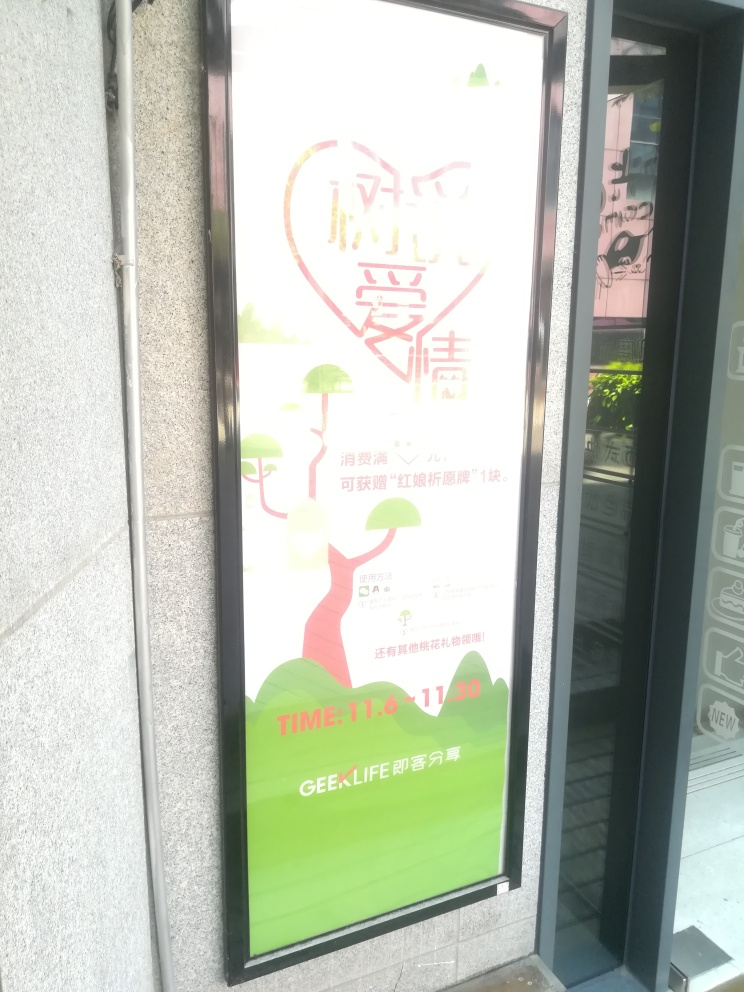Would this image attract its target audience effectively? Given the bright colors and symbolic heart motif, the image might attract an audience interested in community, environment, or personal relationships. However, the effectiveness of the attraction is tempered by the overexposure, which obscures the details that would provide more context and make the message clearer. 